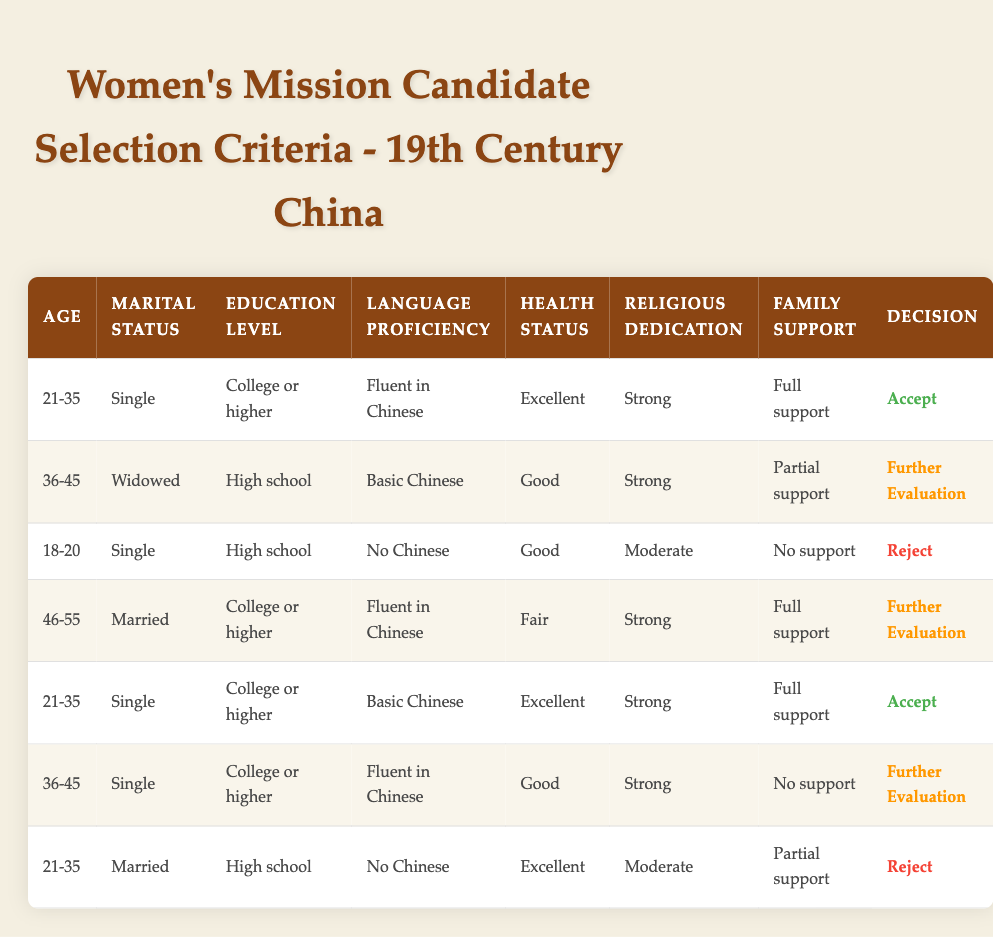What is the language proficiency required for candidates aged 21-35 who are accepted? The row for candidates aged 21-35 who are accepted indicates they must be fluent in Chinese.
Answer: Fluent in Chinese How many candidates fall under the "Further Evaluation" decision? There are three specific rules in the table where the decision is "Further Evaluation." These rules correspond to candidates aged 36-45 (Widowed, High school, Basic Chinese), aged 46-55 (Married, College or higher, Fluent in Chinese), and aged 36-45 (Single, College or higher, Fluent in Chinese with no family support).
Answer: Three candidates What factors lead to rejecting candidates aged 18-20? The candidates aged 18-20 who are rejected have a high school education, no proficiency in Chinese, good health status, moderate religious dedication, and no family support. These combinations categorize them as unsuitable for acceptance.
Answer: No Chinese, moderate dedication, no support What is the oldest age of candidates who are accepted? The table shows that the highest age of accepted candidates is 35, impacted by their marital status, education level, health status, and full family support. The row with candidates aged 21-35 who are single and accepted confirms this is the maximum age bracket.
Answer: 35 Is there a candidate that has a college education and is married with excellent health? There is one candidate fitting this description (age 46-55, married, college education, fair health), but the language proficiency is fluent in Chinese, and they are under "Further Evaluation," hence they don't meet the acceptance criteria.
Answer: No What is the total number of candidates who are either accepted or under further evaluation? Candidates accepted are two (both ages 21-35). The candidates under further evaluation are three (two aged 36-45 and one aged 46-55). Thus, the total is 2 (accepted) + 3 (further evaluation) = 5.
Answer: Five candidates What are the religious dedication levels of candidates who are accepted? The two accepted candidates both have a strong religious dedication. The results found within their rows in the table validate this consistent level across both entries.
Answer: Strong How many candidates are Single and have a health status of Excellent? Referring to the table, there are two candidates who are single and also have an excellent health status: one aged 21-35 (college or higher) and another aged 21-35 (high school). By counting, the total succeeds as 2.
Answer: Two candidates 